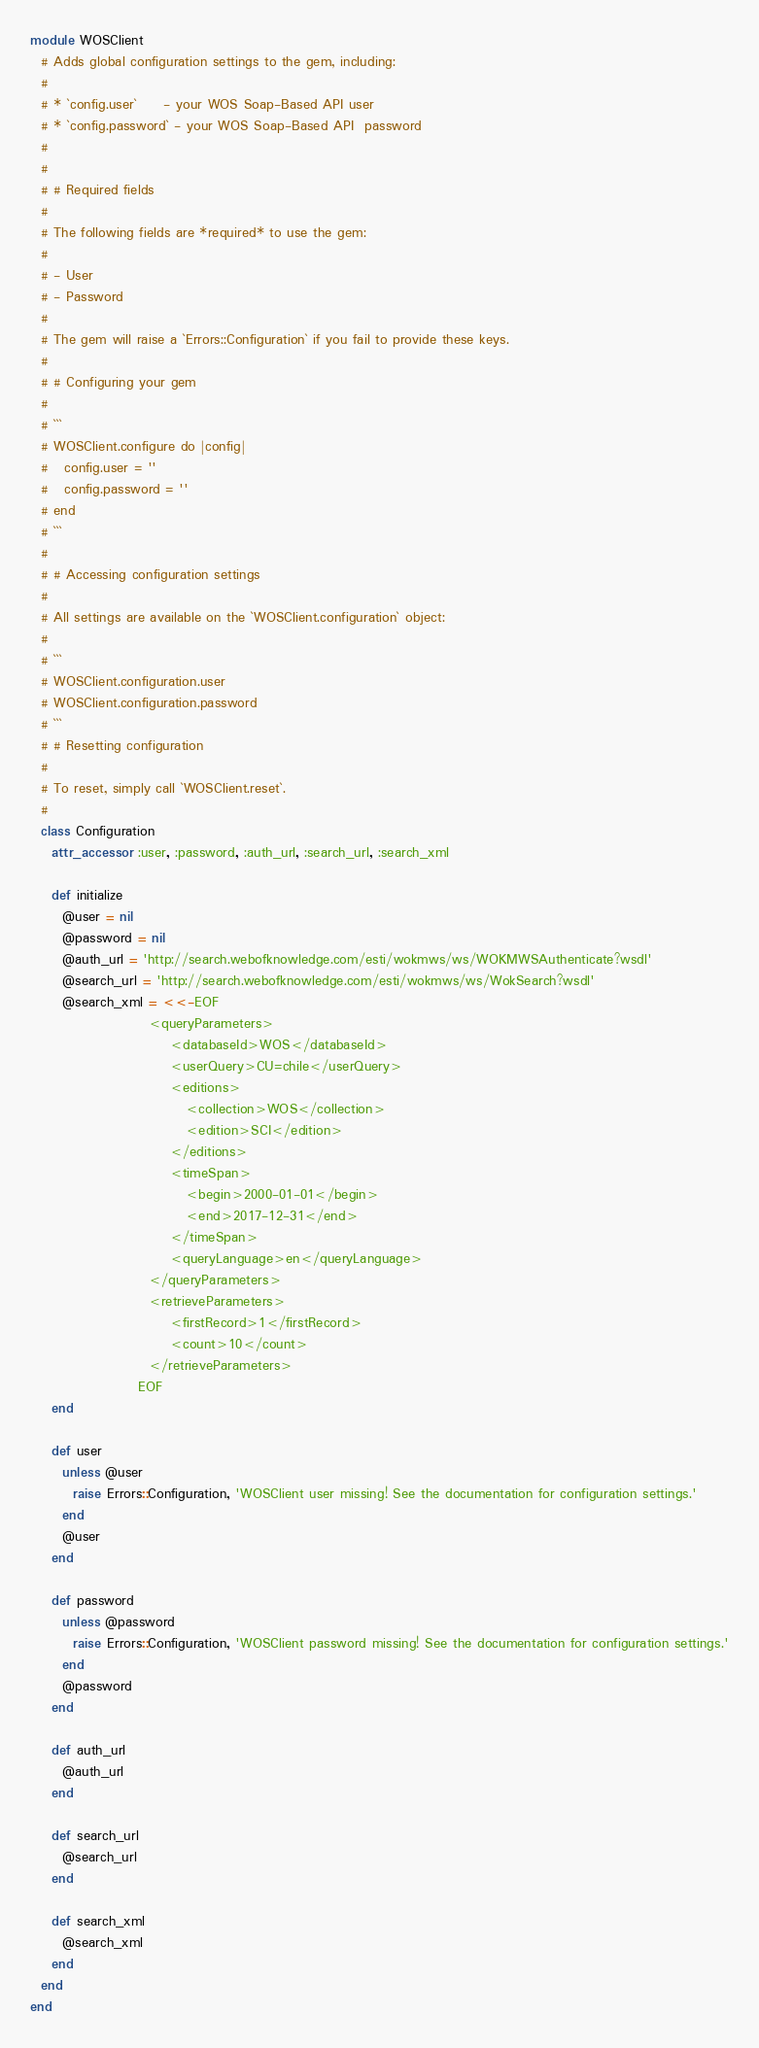<code> <loc_0><loc_0><loc_500><loc_500><_Ruby_>module WOSClient
  # Adds global configuration settings to the gem, including:
  #
  # * `config.user`     - your WOS Soap-Based API user
  # * `config.password` - your WOS Soap-Based API  password
  #
  #
  # # Required fields
  #
  # The following fields are *required* to use the gem:
  #
  # - User
  # - Password
  #
  # The gem will raise a `Errors::Configuration` if you fail to provide these keys.
  #
  # # Configuring your gem
  #
  # ```
  # WOSClient.configure do |config|
  #   config.user = ''
  #   config.password = ''
  # end
  # ```
  #
  # # Accessing configuration settings
  #
  # All settings are available on the `WOSClient.configuration` object:
  #
  # ```
  # WOSClient.configuration.user
  # WOSClient.configuration.password
  # ```
  # # Resetting configuration
  #
  # To reset, simply call `WOSClient.reset`.
  #
  class Configuration
    attr_accessor :user, :password, :auth_url, :search_url, :search_xml

    def initialize
      @user = nil
      @password = nil
      @auth_url = 'http://search.webofknowledge.com/esti/wokmws/ws/WOKMWSAuthenticate?wsdl'
      @search_url = 'http://search.webofknowledge.com/esti/wokmws/ws/WokSearch?wsdl'
      @search_xml = <<-EOF
                      <queryParameters>
                          <databaseId>WOS</databaseId>
                          <userQuery>CU=chile</userQuery>
                          <editions>
                             <collection>WOS</collection>
                             <edition>SCI</edition>
                          </editions>
                          <timeSpan>
                             <begin>2000-01-01</begin>
                             <end>2017-12-31</end>
                          </timeSpan>
                          <queryLanguage>en</queryLanguage>
                      </queryParameters>
                      <retrieveParameters>
                          <firstRecord>1</firstRecord>
                          <count>10</count>
                      </retrieveParameters>
                    EOF
    end

    def user
      unless @user
        raise Errors::Configuration, 'WOSClient user missing! See the documentation for configuration settings.'
      end
      @user
    end

    def password
      unless @password
        raise Errors::Configuration, 'WOSClient password missing! See the documentation for configuration settings.'
      end
      @password
    end

    def auth_url
      @auth_url
    end

    def search_url
      @search_url
    end

    def search_xml
      @search_xml
    end
  end
end
</code> 